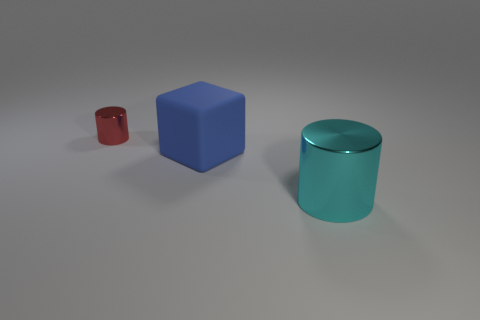Is there anything else that is the same size as the red thing?
Provide a short and direct response. No. There is a small cylinder on the left side of the shiny cylinder that is in front of the red object; is there a big cyan object that is right of it?
Your response must be concise. Yes. What number of objects are either metallic things that are in front of the small red metal thing or cylinders that are in front of the tiny metallic thing?
Make the answer very short. 1. Is the big thing that is in front of the blue rubber block made of the same material as the small cylinder?
Offer a terse response. Yes. There is a metal object that is behind the shiny cylinder that is to the right of the small red cylinder; what is its color?
Provide a succinct answer. Red. What material is the red object that is the same shape as the cyan thing?
Your answer should be very brief. Metal. There is a big object left of the metal cylinder to the right of the metal thing that is behind the cyan metal cylinder; what color is it?
Ensure brevity in your answer.  Blue. How many things are either large cyan cylinders or cyan balls?
Your answer should be compact. 1. What number of other shiny objects have the same shape as the tiny red object?
Offer a terse response. 1. Do the block and the object that is behind the large blue rubber object have the same material?
Your response must be concise. No. 